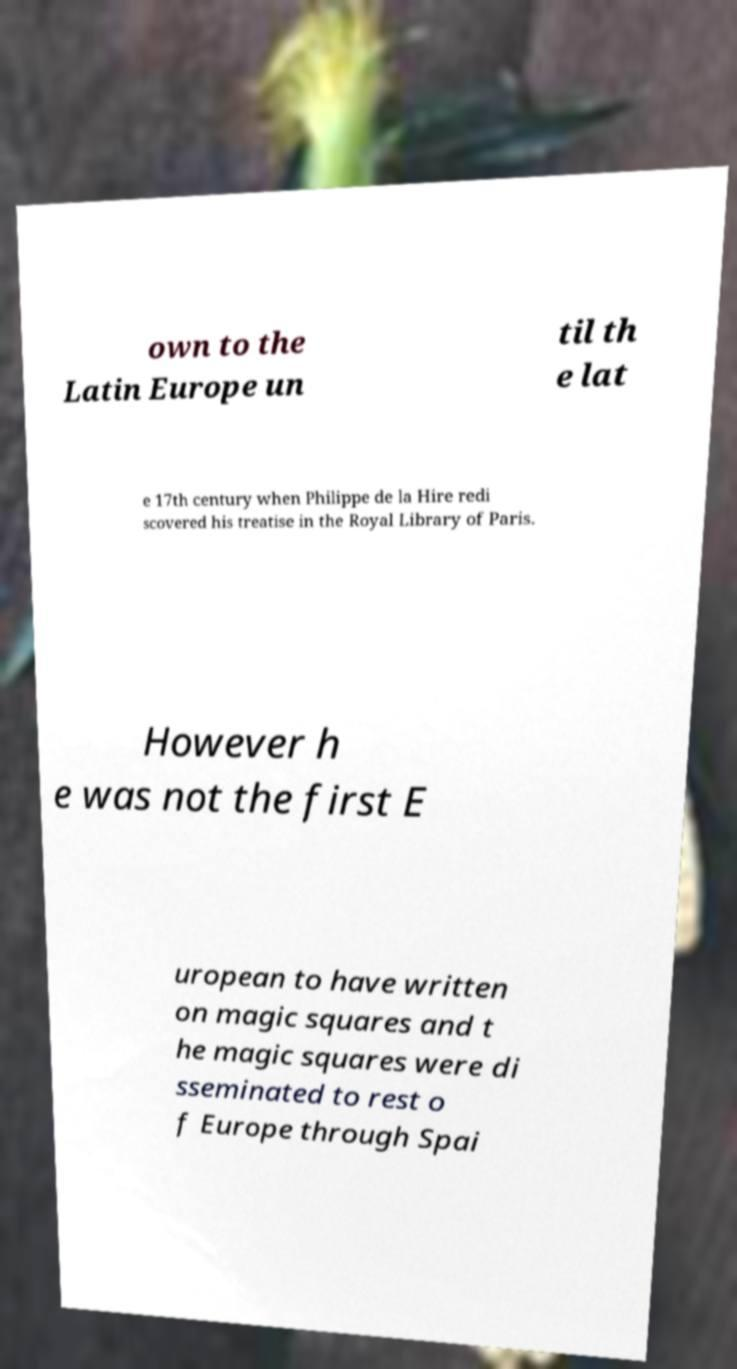I need the written content from this picture converted into text. Can you do that? own to the Latin Europe un til th e lat e 17th century when Philippe de la Hire redi scovered his treatise in the Royal Library of Paris. However h e was not the first E uropean to have written on magic squares and t he magic squares were di sseminated to rest o f Europe through Spai 